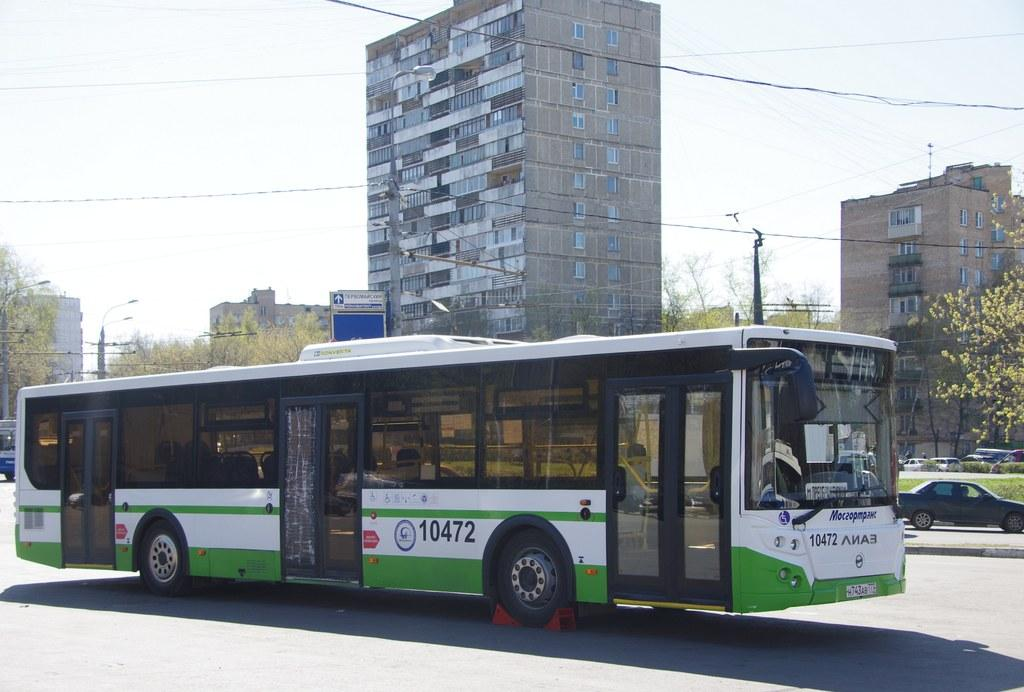<image>
Share a concise interpretation of the image provided. A city bus with the numbers 10472 on its side. 